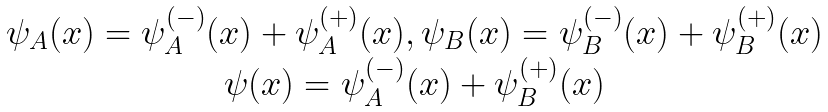Convert formula to latex. <formula><loc_0><loc_0><loc_500><loc_500>\begin{array} { c } \psi _ { A } ( x ) = \psi _ { A } ^ { ( - ) } ( x ) + \psi _ { A } ^ { ( + ) } ( x ) , \psi _ { B } ( x ) = \psi _ { B } ^ { ( - ) } ( x ) + \psi _ { B } ^ { ( + ) } ( x ) \\ \psi ( x ) = \psi _ { A } ^ { ( - ) } ( x ) + \psi _ { B } ^ { ( + ) } ( x ) \end{array}</formula> 